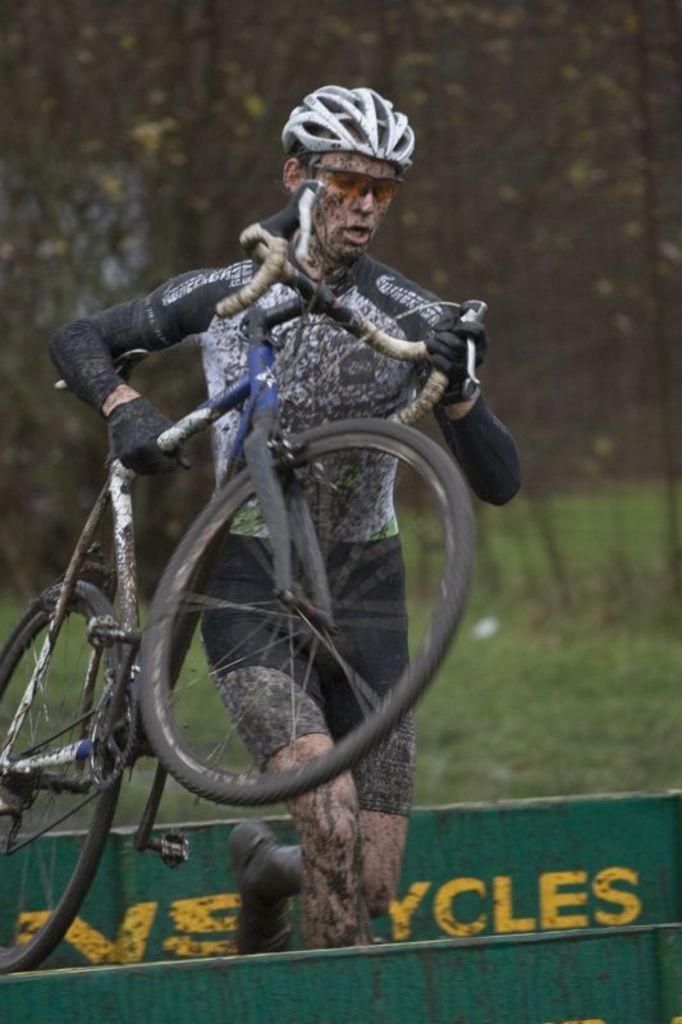Describe this image in one or two sentences. In this picture, we can see a person holding a bicycle, and we can see some object with some text, and we can see the blurred background. 